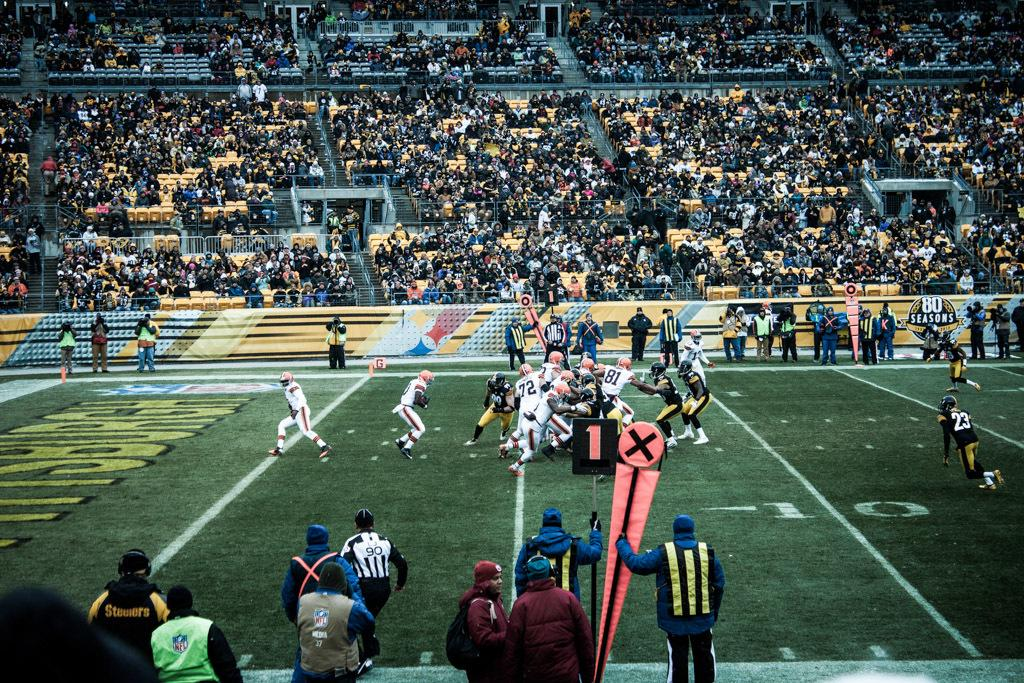<image>
Create a compact narrative representing the image presented. Football stadium that has a referee with a number 90 on his back. 